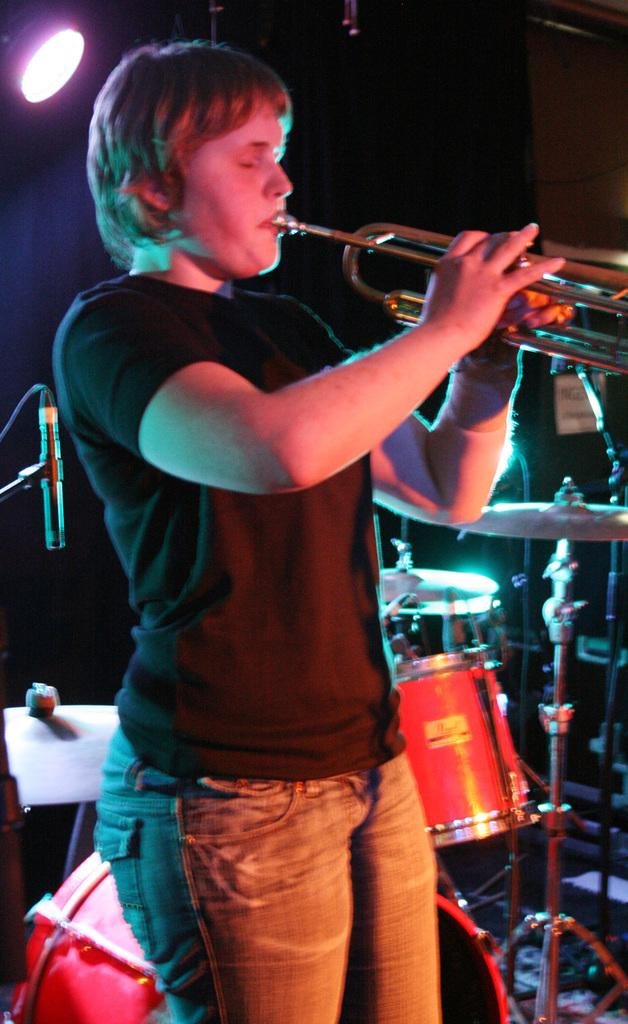What is the person in the image doing? There is a person playing a trumpet in the image. What other musical instrument can be seen in the image? There is a musical instrument in the background. Can you describe the lighting in the image? There is a light visible in the image. What equipment is present for amplifying sound? There is a mic with a mic stand in the image. What type of wood is used to make the peace symbol in the image? There is no peace symbol present in the image, so it is not possible to determine the type of wood used. 